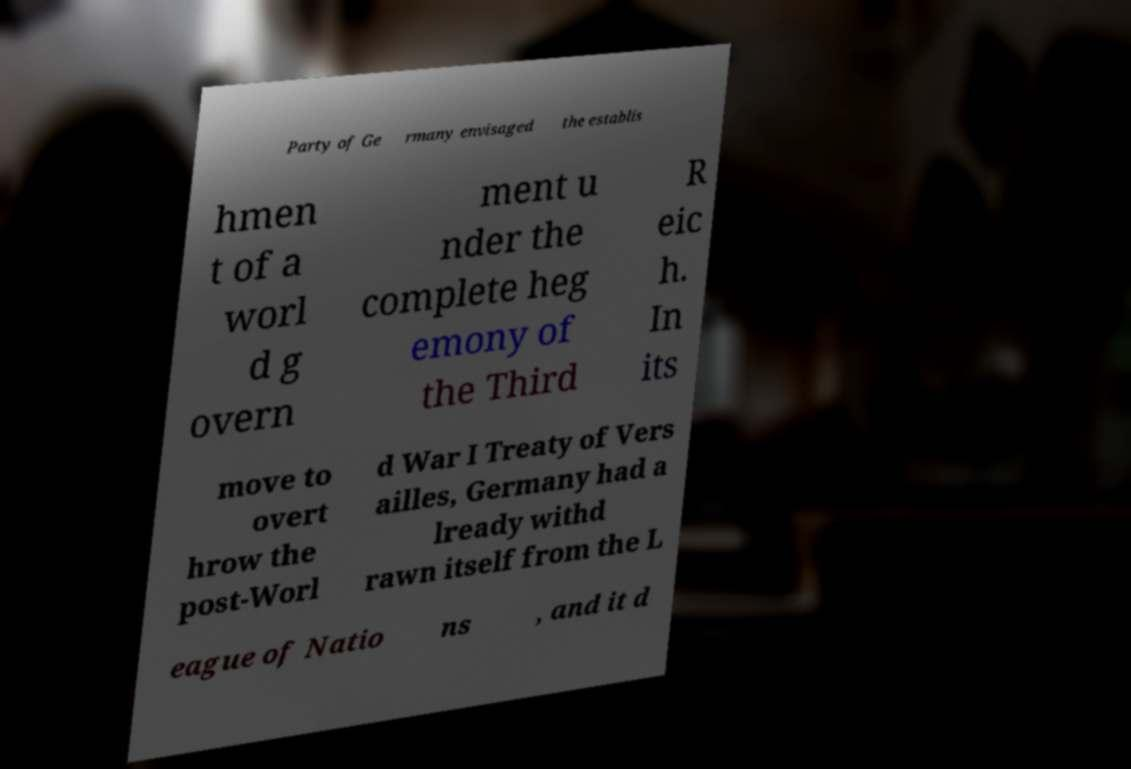Please read and relay the text visible in this image. What does it say? Party of Ge rmany envisaged the establis hmen t of a worl d g overn ment u nder the complete heg emony of the Third R eic h. In its move to overt hrow the post-Worl d War I Treaty of Vers ailles, Germany had a lready withd rawn itself from the L eague of Natio ns , and it d 